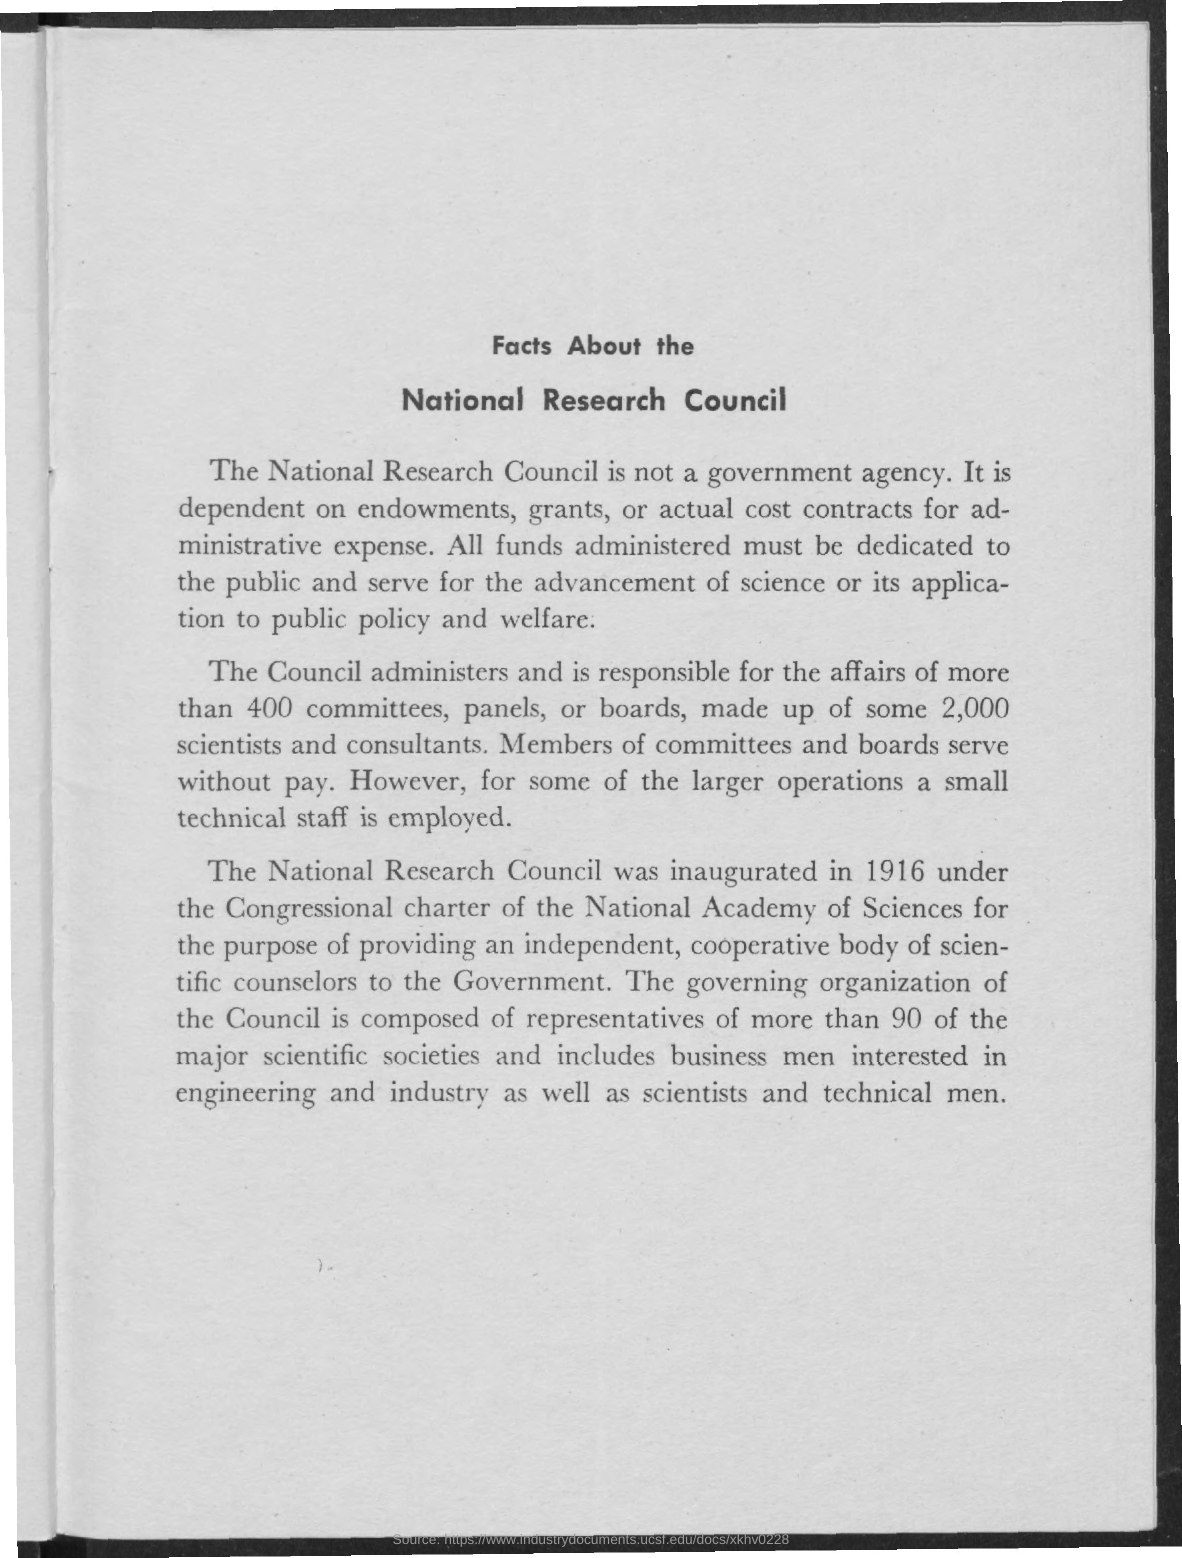Indicate a few pertinent items in this graphic. The National Research Council was inaugurated in 1916. 